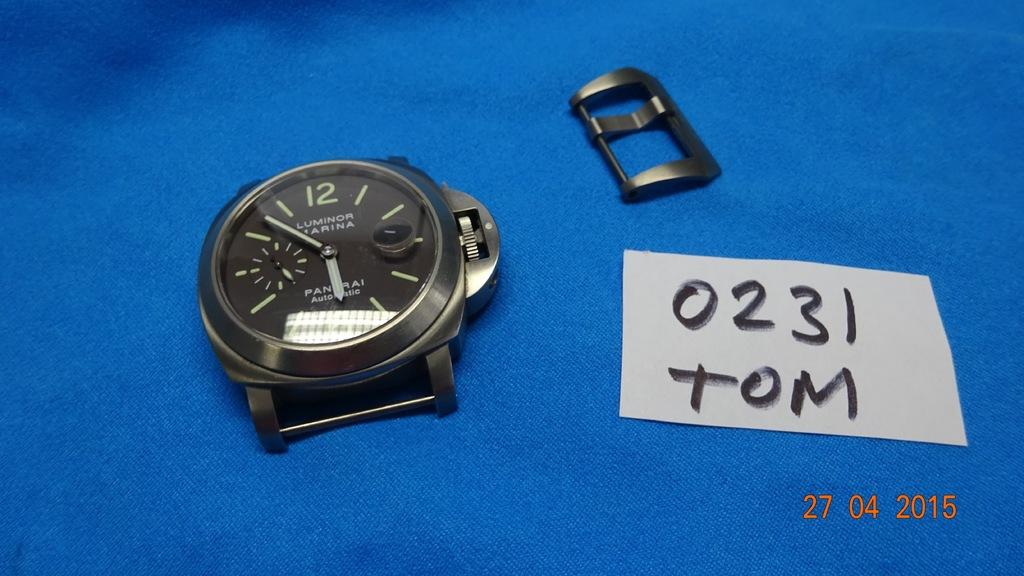<image>
Give a short and clear explanation of the subsequent image. A PANERAI watch with black face placed on a blue surface. 